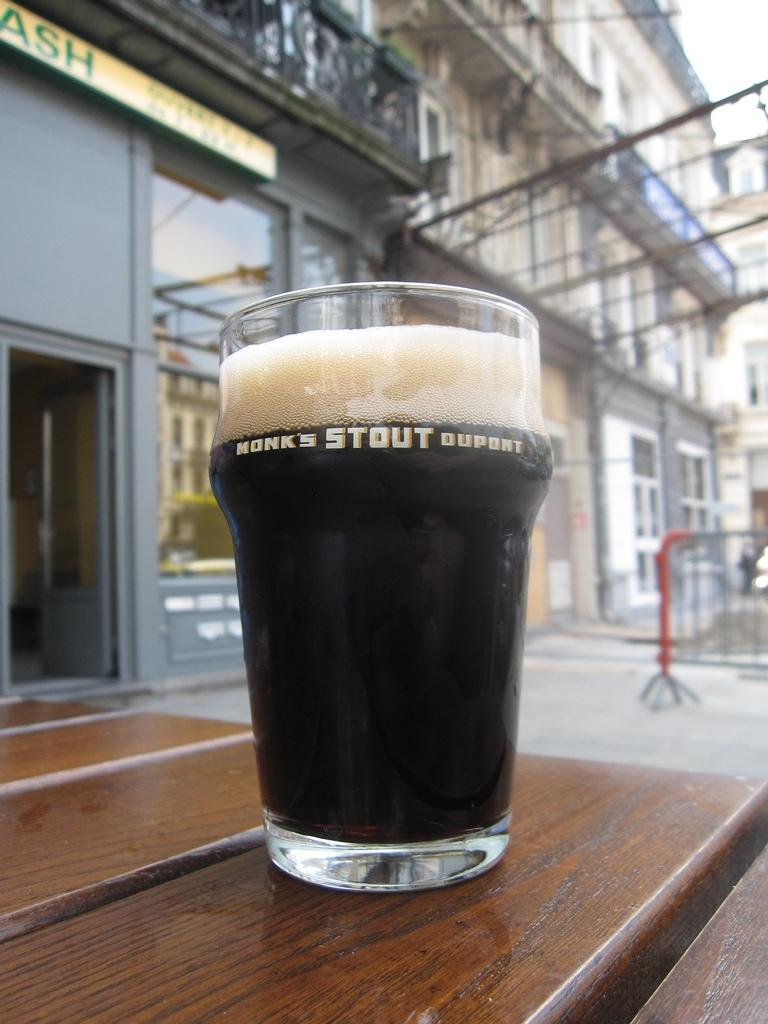<image>
Provide a brief description of the given image. A glass of dark beer with a big head that says Honk's Stout Dupont. 